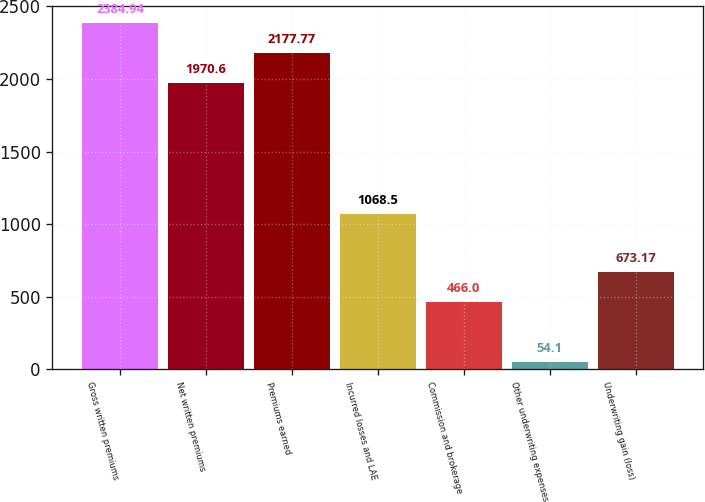<chart> <loc_0><loc_0><loc_500><loc_500><bar_chart><fcel>Gross written premiums<fcel>Net written premiums<fcel>Premiums earned<fcel>Incurred losses and LAE<fcel>Commission and brokerage<fcel>Other underwriting expenses<fcel>Underwriting gain (loss)<nl><fcel>2384.94<fcel>1970.6<fcel>2177.77<fcel>1068.5<fcel>466<fcel>54.1<fcel>673.17<nl></chart> 